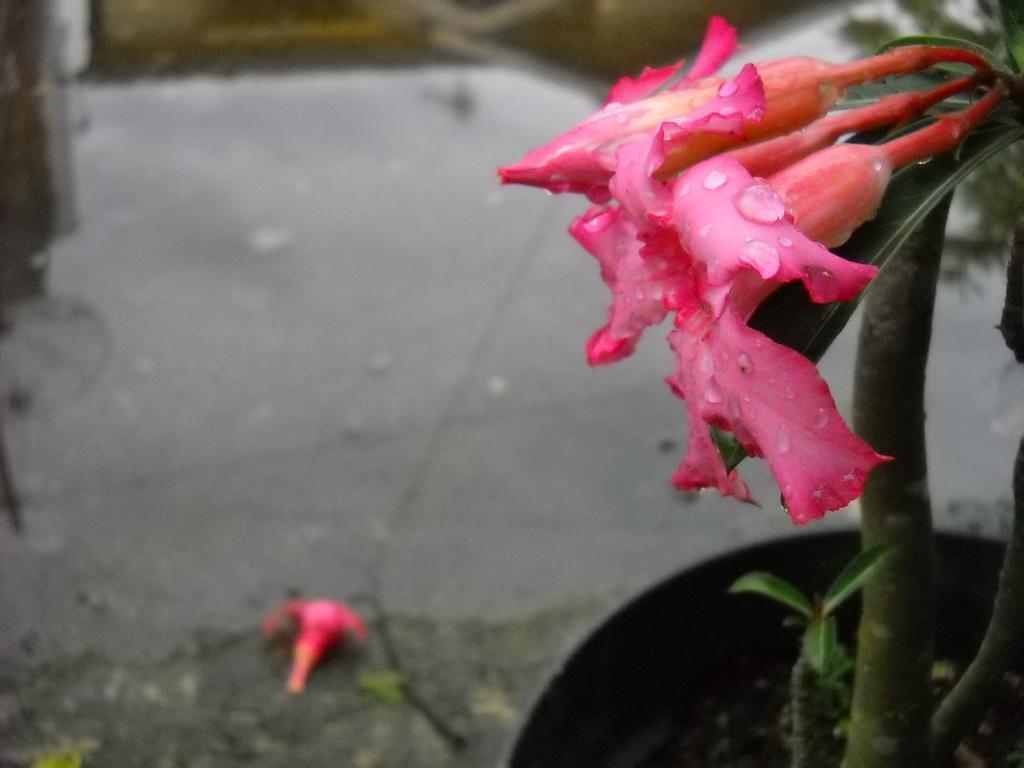Describe this image in one or two sentences. We can see pink flowers and house plant. In the background it is blur. 